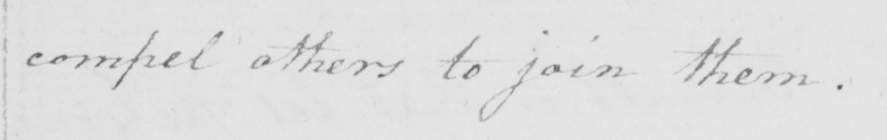Can you read and transcribe this handwriting? compel others to join them . 